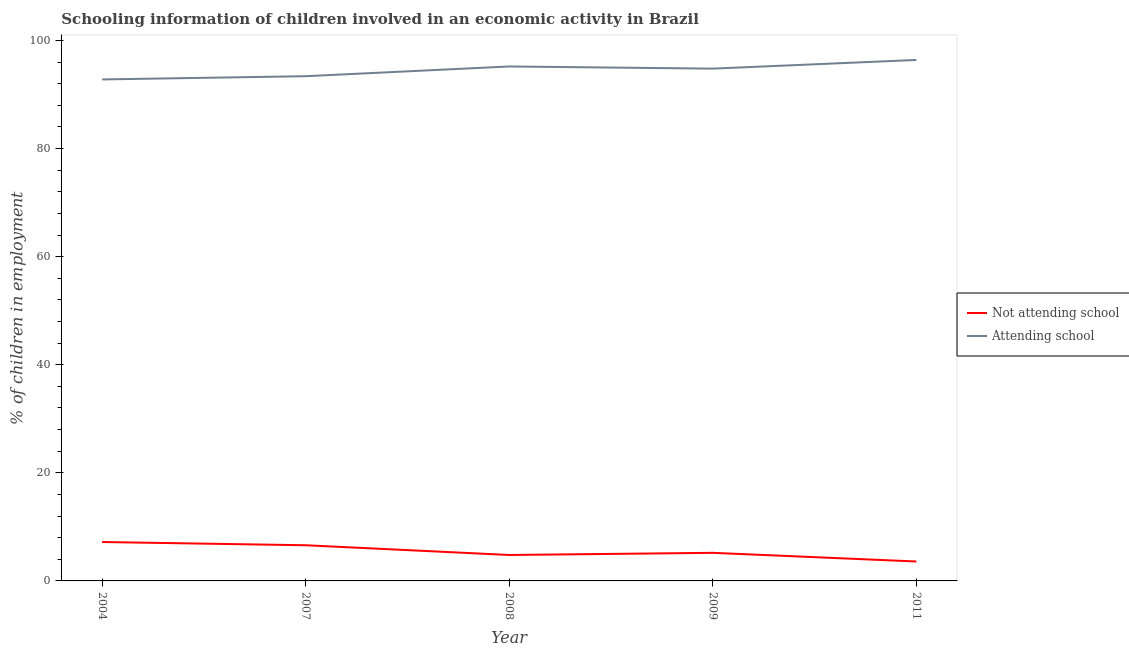How many different coloured lines are there?
Ensure brevity in your answer.  2. Does the line corresponding to percentage of employed children who are attending school intersect with the line corresponding to percentage of employed children who are not attending school?
Offer a terse response. No. Across all years, what is the maximum percentage of employed children who are not attending school?
Provide a succinct answer. 7.2. Across all years, what is the minimum percentage of employed children who are not attending school?
Offer a terse response. 3.59. What is the total percentage of employed children who are attending school in the graph?
Make the answer very short. 472.61. What is the difference between the percentage of employed children who are attending school in 2009 and that in 2011?
Keep it short and to the point. -1.61. What is the difference between the percentage of employed children who are attending school in 2007 and the percentage of employed children who are not attending school in 2008?
Ensure brevity in your answer.  88.6. What is the average percentage of employed children who are attending school per year?
Provide a short and direct response. 94.52. In the year 2008, what is the difference between the percentage of employed children who are attending school and percentage of employed children who are not attending school?
Offer a terse response. 90.4. What is the ratio of the percentage of employed children who are not attending school in 2008 to that in 2011?
Keep it short and to the point. 1.34. What is the difference between the highest and the second highest percentage of employed children who are not attending school?
Provide a short and direct response. 0.6. What is the difference between the highest and the lowest percentage of employed children who are attending school?
Give a very brief answer. 3.61. Is the sum of the percentage of employed children who are attending school in 2007 and 2009 greater than the maximum percentage of employed children who are not attending school across all years?
Offer a very short reply. Yes. Is the percentage of employed children who are not attending school strictly greater than the percentage of employed children who are attending school over the years?
Provide a succinct answer. No. How many lines are there?
Your answer should be very brief. 2. What is the difference between two consecutive major ticks on the Y-axis?
Your response must be concise. 20. Are the values on the major ticks of Y-axis written in scientific E-notation?
Your answer should be very brief. No. Does the graph contain grids?
Your answer should be very brief. No. How many legend labels are there?
Ensure brevity in your answer.  2. How are the legend labels stacked?
Offer a terse response. Vertical. What is the title of the graph?
Make the answer very short. Schooling information of children involved in an economic activity in Brazil. What is the label or title of the Y-axis?
Your answer should be very brief. % of children in employment. What is the % of children in employment of Attending school in 2004?
Your answer should be compact. 92.8. What is the % of children in employment of Attending school in 2007?
Make the answer very short. 93.4. What is the % of children in employment of Attending school in 2008?
Your answer should be very brief. 95.2. What is the % of children in employment of Attending school in 2009?
Your answer should be very brief. 94.8. What is the % of children in employment in Not attending school in 2011?
Provide a short and direct response. 3.59. What is the % of children in employment in Attending school in 2011?
Give a very brief answer. 96.41. Across all years, what is the maximum % of children in employment of Attending school?
Ensure brevity in your answer.  96.41. Across all years, what is the minimum % of children in employment of Not attending school?
Provide a succinct answer. 3.59. Across all years, what is the minimum % of children in employment in Attending school?
Give a very brief answer. 92.8. What is the total % of children in employment of Not attending school in the graph?
Offer a terse response. 27.39. What is the total % of children in employment of Attending school in the graph?
Offer a very short reply. 472.61. What is the difference between the % of children in employment in Attending school in 2004 and that in 2008?
Provide a short and direct response. -2.4. What is the difference between the % of children in employment in Not attending school in 2004 and that in 2009?
Your answer should be compact. 2. What is the difference between the % of children in employment of Not attending school in 2004 and that in 2011?
Provide a short and direct response. 3.61. What is the difference between the % of children in employment in Attending school in 2004 and that in 2011?
Ensure brevity in your answer.  -3.61. What is the difference between the % of children in employment of Not attending school in 2007 and that in 2009?
Provide a succinct answer. 1.4. What is the difference between the % of children in employment of Not attending school in 2007 and that in 2011?
Give a very brief answer. 3.01. What is the difference between the % of children in employment in Attending school in 2007 and that in 2011?
Provide a succinct answer. -3.01. What is the difference between the % of children in employment in Not attending school in 2008 and that in 2011?
Your answer should be very brief. 1.21. What is the difference between the % of children in employment in Attending school in 2008 and that in 2011?
Your answer should be compact. -1.21. What is the difference between the % of children in employment of Not attending school in 2009 and that in 2011?
Provide a short and direct response. 1.61. What is the difference between the % of children in employment in Attending school in 2009 and that in 2011?
Your response must be concise. -1.61. What is the difference between the % of children in employment of Not attending school in 2004 and the % of children in employment of Attending school in 2007?
Keep it short and to the point. -86.2. What is the difference between the % of children in employment of Not attending school in 2004 and the % of children in employment of Attending school in 2008?
Ensure brevity in your answer.  -88. What is the difference between the % of children in employment of Not attending school in 2004 and the % of children in employment of Attending school in 2009?
Keep it short and to the point. -87.6. What is the difference between the % of children in employment of Not attending school in 2004 and the % of children in employment of Attending school in 2011?
Make the answer very short. -89.21. What is the difference between the % of children in employment of Not attending school in 2007 and the % of children in employment of Attending school in 2008?
Your answer should be very brief. -88.6. What is the difference between the % of children in employment in Not attending school in 2007 and the % of children in employment in Attending school in 2009?
Make the answer very short. -88.2. What is the difference between the % of children in employment in Not attending school in 2007 and the % of children in employment in Attending school in 2011?
Make the answer very short. -89.81. What is the difference between the % of children in employment in Not attending school in 2008 and the % of children in employment in Attending school in 2009?
Make the answer very short. -90. What is the difference between the % of children in employment in Not attending school in 2008 and the % of children in employment in Attending school in 2011?
Your answer should be compact. -91.61. What is the difference between the % of children in employment of Not attending school in 2009 and the % of children in employment of Attending school in 2011?
Provide a succinct answer. -91.21. What is the average % of children in employment of Not attending school per year?
Provide a succinct answer. 5.48. What is the average % of children in employment in Attending school per year?
Provide a short and direct response. 94.52. In the year 2004, what is the difference between the % of children in employment in Not attending school and % of children in employment in Attending school?
Provide a succinct answer. -85.6. In the year 2007, what is the difference between the % of children in employment of Not attending school and % of children in employment of Attending school?
Provide a succinct answer. -86.8. In the year 2008, what is the difference between the % of children in employment in Not attending school and % of children in employment in Attending school?
Your answer should be very brief. -90.4. In the year 2009, what is the difference between the % of children in employment of Not attending school and % of children in employment of Attending school?
Ensure brevity in your answer.  -89.6. In the year 2011, what is the difference between the % of children in employment of Not attending school and % of children in employment of Attending school?
Give a very brief answer. -92.81. What is the ratio of the % of children in employment of Attending school in 2004 to that in 2008?
Your answer should be very brief. 0.97. What is the ratio of the % of children in employment in Not attending school in 2004 to that in 2009?
Give a very brief answer. 1.38. What is the ratio of the % of children in employment in Attending school in 2004 to that in 2009?
Keep it short and to the point. 0.98. What is the ratio of the % of children in employment in Not attending school in 2004 to that in 2011?
Offer a terse response. 2. What is the ratio of the % of children in employment of Attending school in 2004 to that in 2011?
Keep it short and to the point. 0.96. What is the ratio of the % of children in employment of Not attending school in 2007 to that in 2008?
Give a very brief answer. 1.38. What is the ratio of the % of children in employment in Attending school in 2007 to that in 2008?
Give a very brief answer. 0.98. What is the ratio of the % of children in employment of Not attending school in 2007 to that in 2009?
Ensure brevity in your answer.  1.27. What is the ratio of the % of children in employment in Attending school in 2007 to that in 2009?
Make the answer very short. 0.99. What is the ratio of the % of children in employment in Not attending school in 2007 to that in 2011?
Offer a terse response. 1.84. What is the ratio of the % of children in employment in Attending school in 2007 to that in 2011?
Provide a succinct answer. 0.97. What is the ratio of the % of children in employment in Not attending school in 2008 to that in 2011?
Offer a terse response. 1.34. What is the ratio of the % of children in employment in Attending school in 2008 to that in 2011?
Your answer should be very brief. 0.99. What is the ratio of the % of children in employment of Not attending school in 2009 to that in 2011?
Ensure brevity in your answer.  1.45. What is the ratio of the % of children in employment of Attending school in 2009 to that in 2011?
Your answer should be compact. 0.98. What is the difference between the highest and the second highest % of children in employment in Attending school?
Make the answer very short. 1.21. What is the difference between the highest and the lowest % of children in employment of Not attending school?
Your response must be concise. 3.61. What is the difference between the highest and the lowest % of children in employment of Attending school?
Offer a terse response. 3.61. 